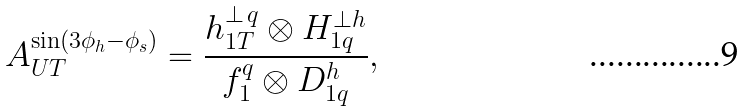<formula> <loc_0><loc_0><loc_500><loc_500>A _ { U T } ^ { \sin ( 3 \phi _ { h } - \phi _ { s } ) } = \frac { h _ { 1 T } ^ { \perp \, q } \otimes H _ { 1 q } ^ { \bot h } } { f _ { 1 } ^ { q } \otimes D _ { 1 q } ^ { h } } ,</formula> 